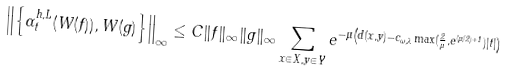Convert formula to latex. <formula><loc_0><loc_0><loc_500><loc_500>\left \| \left \{ \alpha _ { t } ^ { h , L } ( W ( f ) ) , W ( g ) \right \} \right \| _ { \infty } \leq C \| f \| _ { \infty } \| g \| _ { \infty } \sum _ { x \in X , y \in Y } e ^ { - \mu \left ( d ( x , y ) - c _ { \omega , \lambda } \max ( \frac { 2 } { \mu } , e ^ { ( \mu / 2 ) + 1 } ) | t | \right ) }</formula> 